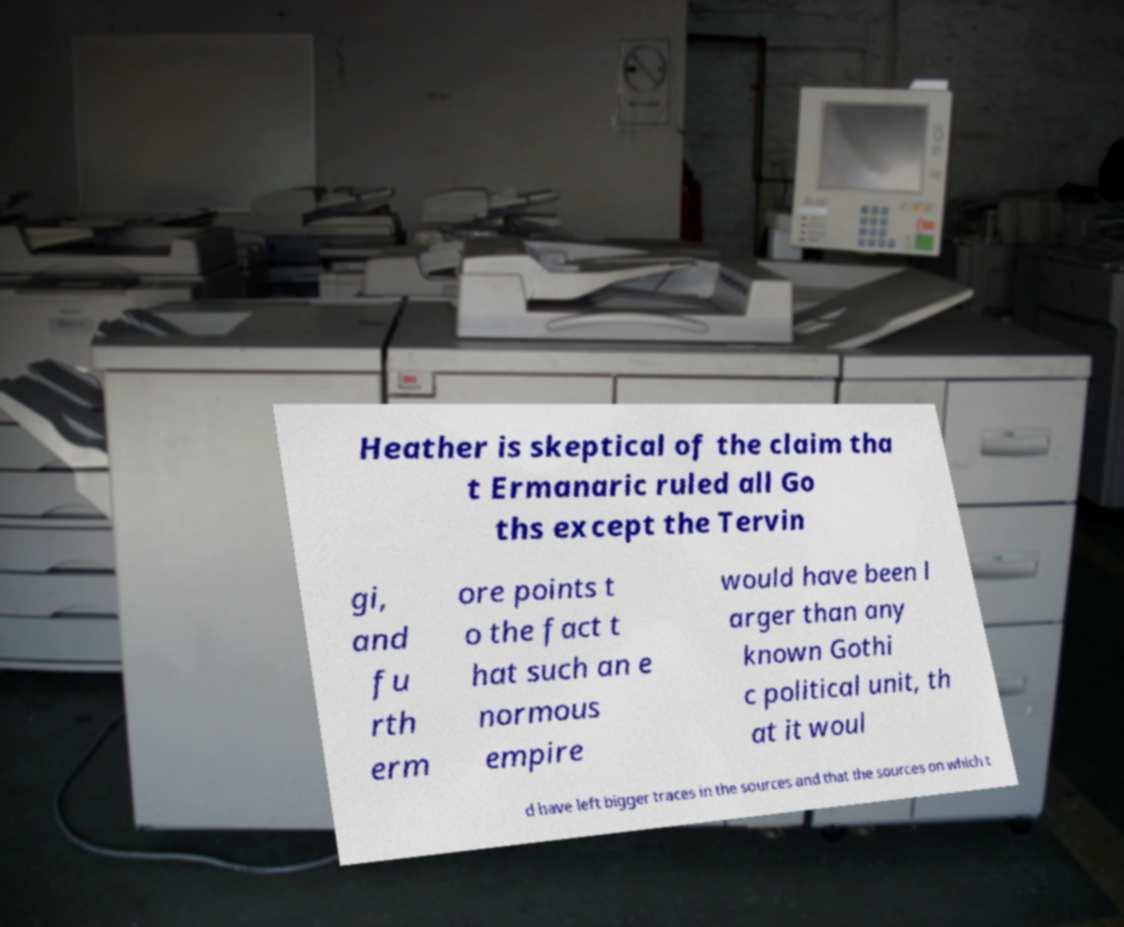For documentation purposes, I need the text within this image transcribed. Could you provide that? Heather is skeptical of the claim tha t Ermanaric ruled all Go ths except the Tervin gi, and fu rth erm ore points t o the fact t hat such an e normous empire would have been l arger than any known Gothi c political unit, th at it woul d have left bigger traces in the sources and that the sources on which t 